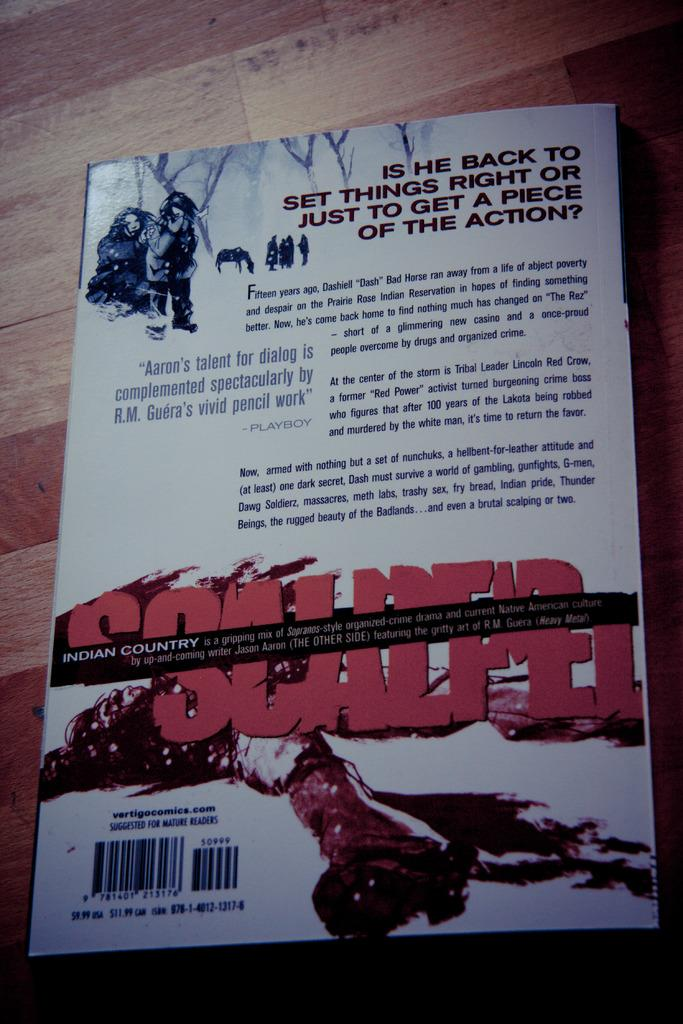<image>
Present a compact description of the photo's key features. A white book has as a description on the cover, "IS HE BACK TO SET THINGS RIGHT OR JUST TO GET A PIECE OF THE ACTION?" 